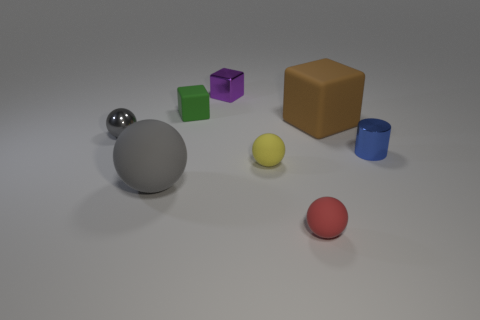Which object is closest to the center of the image? The object closest to the center appears to be the grey sphere. 